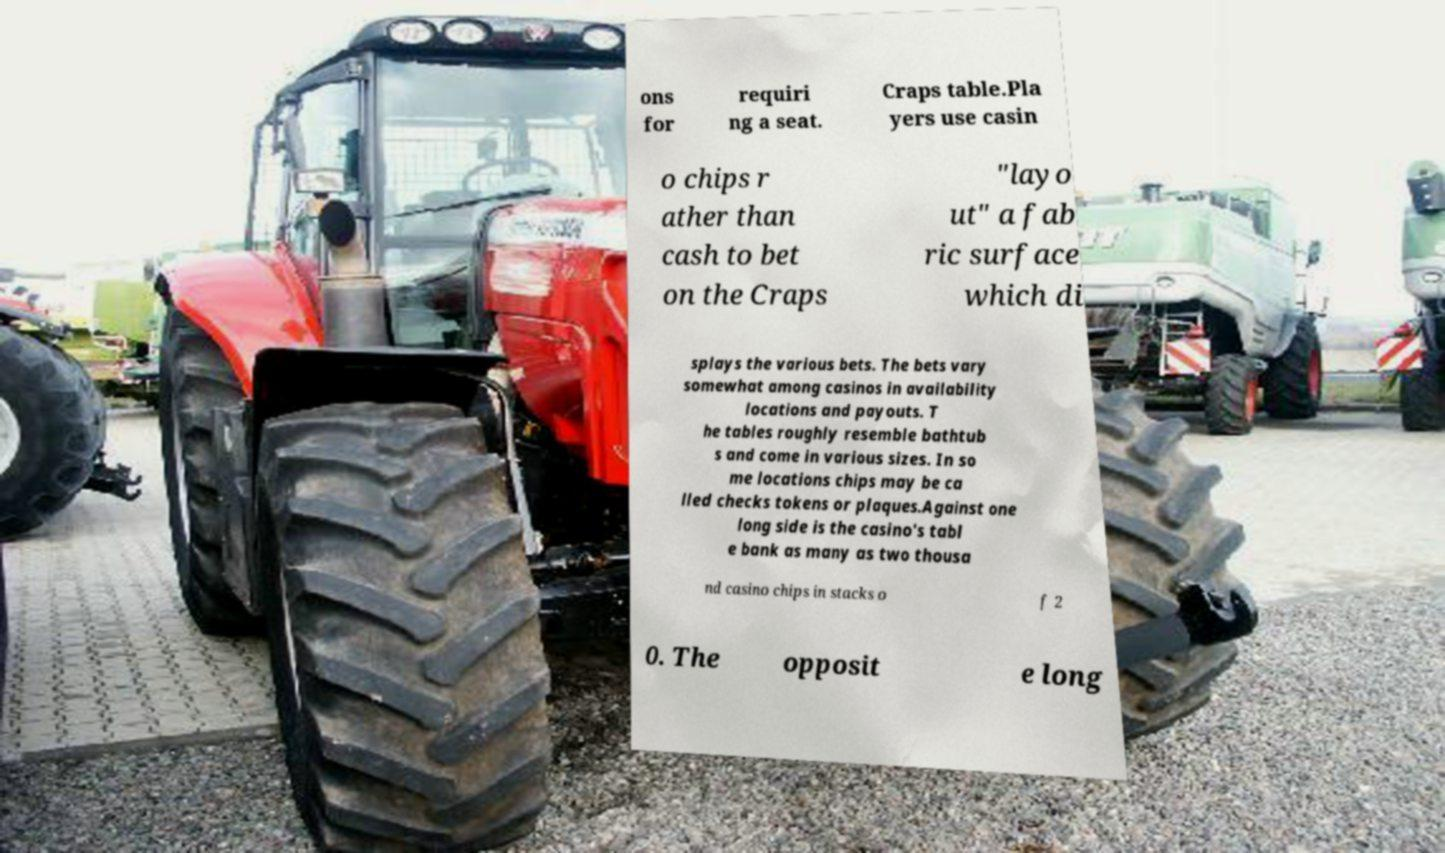Please identify and transcribe the text found in this image. ons for requiri ng a seat. Craps table.Pla yers use casin o chips r ather than cash to bet on the Craps "layo ut" a fab ric surface which di splays the various bets. The bets vary somewhat among casinos in availability locations and payouts. T he tables roughly resemble bathtub s and come in various sizes. In so me locations chips may be ca lled checks tokens or plaques.Against one long side is the casino's tabl e bank as many as two thousa nd casino chips in stacks o f 2 0. The opposit e long 